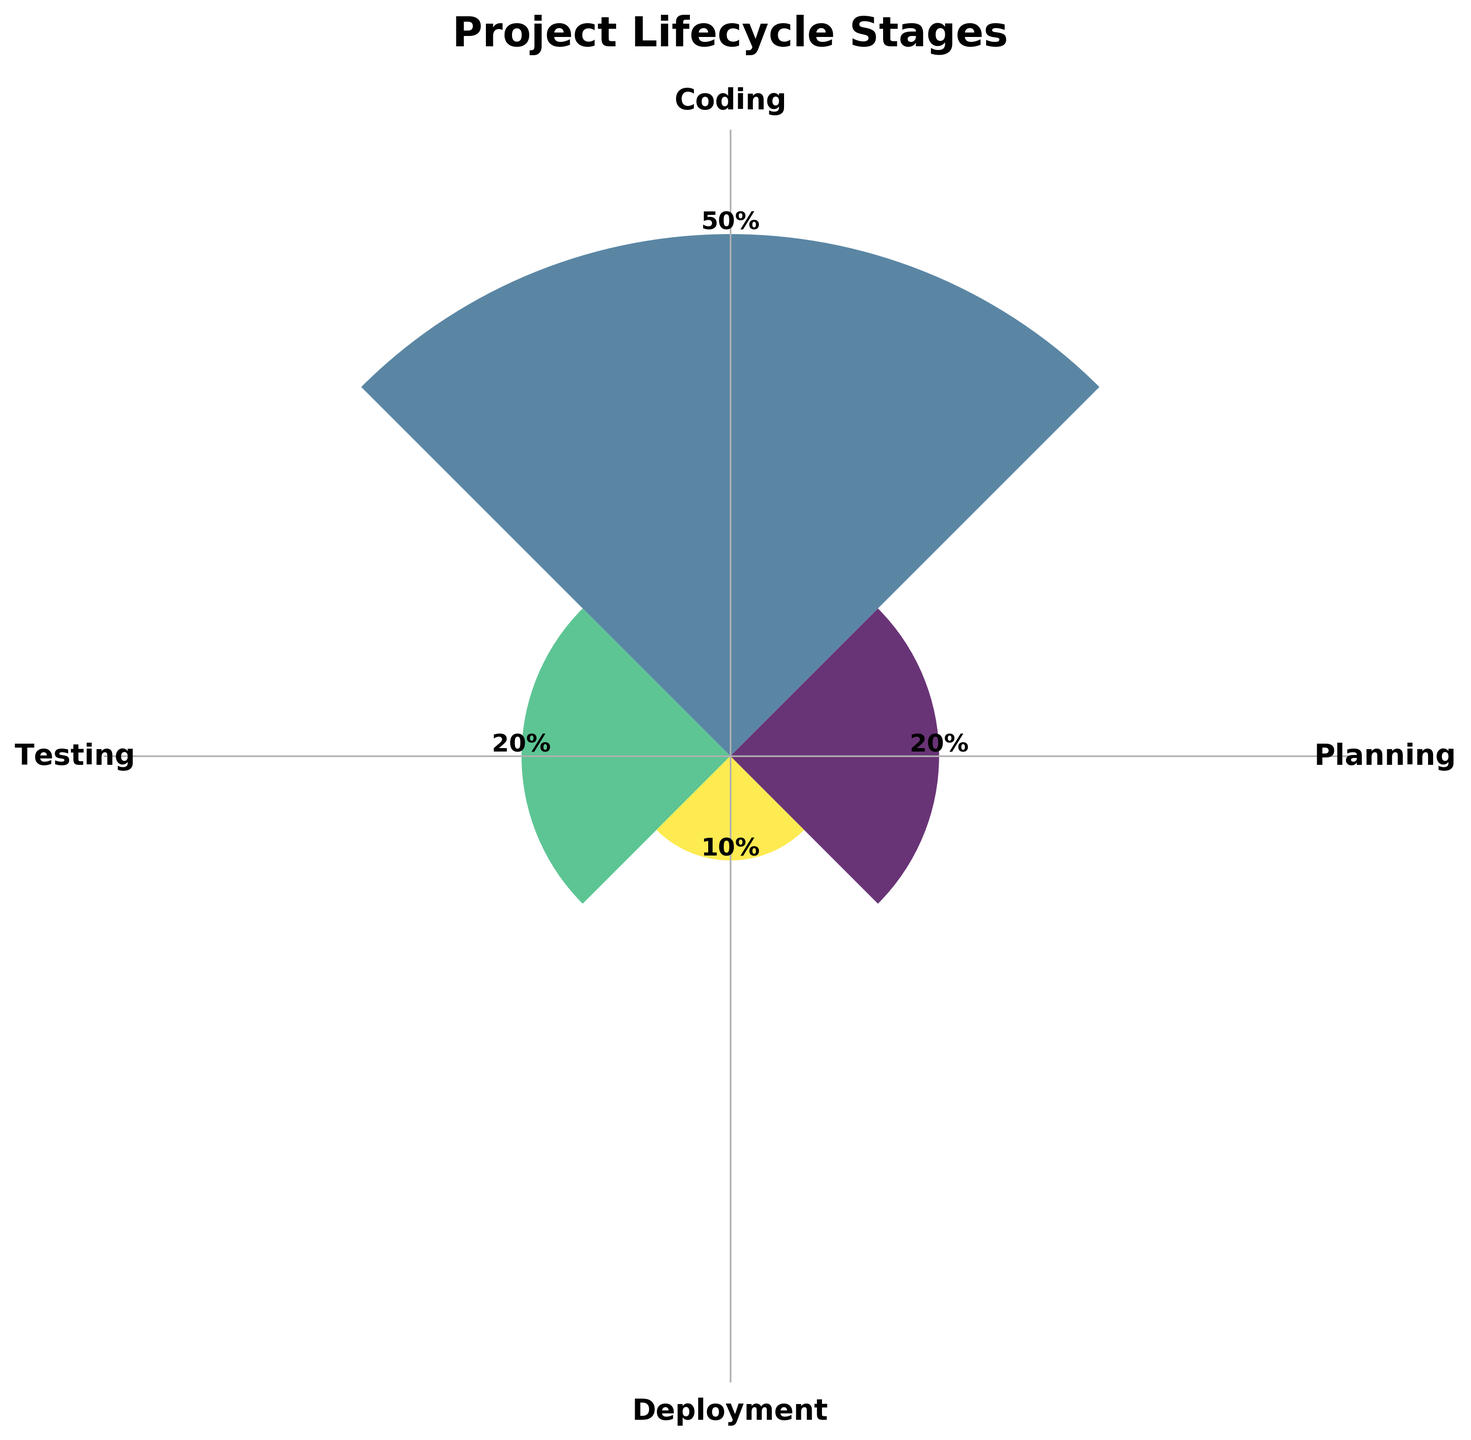What is the title of the chart? The title of the chart is usually displayed prominently at the top of the figure. In this case, "Project Lifecycle Stages" is clearly indicated as the title.
Answer: Project Lifecycle Stages How many stages are represented in the chart? By counting the distinct labels around the chart, we can identify four stages present in the figure.
Answer: 4 Which stage has the highest proportion of time spent? By looking at the height of the bars or the values annotated at the top of the bars, the Coding stage has the highest proportion with 50%.
Answer: Coding Which two stages have the same proportion of time spent? By comparing the heights of the bars and the values, Planning and Testing both have a proportion of 20%.
Answer: Planning and Testing What is the combined proportion of time spent on Planning and Deployment? The proportion for Planning is 20% and for Deployment is 10%. Adding them together, 20% + 10% = 30%.
Answer: 30% Is the proportion of time spent on Testing greater than or equal to Deployment? From the figure, Testing has a 20% proportion and Deployment has a 10% proportion, thus 20% is greater than 10%.
Answer: Yes Which stage has the smallest proportion of time spent? By comparing the annotated proportions, Deployment has the smallest proportion with 10%.
Answer: Deployment How much more time is spent on Coding than Deployment? The proportion for Coding is 50% and for Deployment is 10%. The difference is 50% - 10%, which is 40%.
Answer: 40% What is the average proportion of time spent across all stages? Sum the proportions: 20% + 50% + 20% + 10% = 100%. Then divide by the number of stages, which is 4. So, 100% / 4 = 25%.
Answer: 25% If the Testing stage were to increase by 15%, what would be the new proportion for Testing? The current proportion for Testing is 20%. If it increases by 15%, then 20% + 15% = 35%.
Answer: 35% 